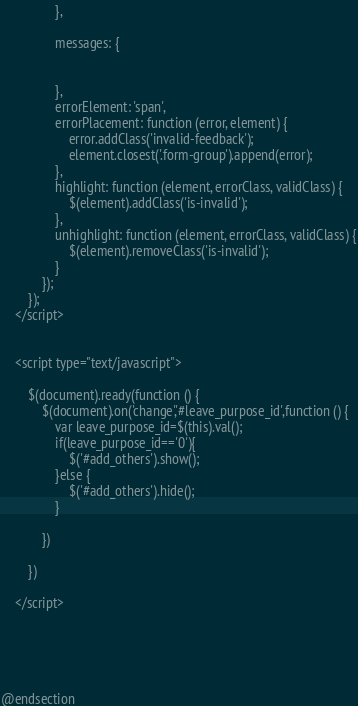<code> <loc_0><loc_0><loc_500><loc_500><_PHP_>
                },

                messages: {


                },
                errorElement: 'span',
                errorPlacement: function (error, element) {
                    error.addClass('invalid-feedback');
                    element.closest('.form-group').append(error);
                },
                highlight: function (element, errorClass, validClass) {
                    $(element).addClass('is-invalid');
                },
                unhighlight: function (element, errorClass, validClass) {
                    $(element).removeClass('is-invalid');
                }
            });
        });
    </script>


    <script type="text/javascript">

        $(document).ready(function () {
            $(document).on('change','#leave_purpose_id',function () {
                var leave_purpose_id=$(this).val();
                if(leave_purpose_id=='0'){
                    $('#add_others').show();
                }else {
                    $('#add_others').hide();
                }

            })

        })

    </script>





@endsection</code> 